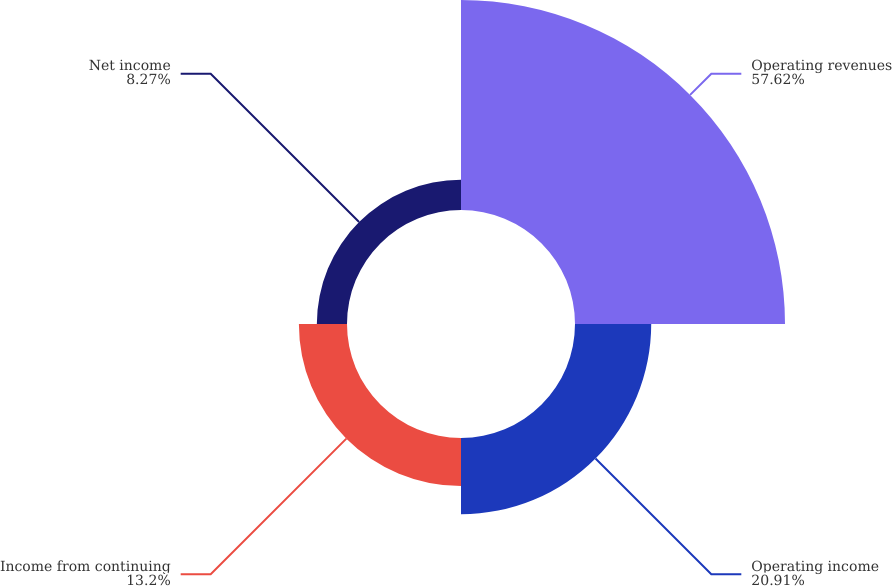Convert chart. <chart><loc_0><loc_0><loc_500><loc_500><pie_chart><fcel>Operating revenues<fcel>Operating income<fcel>Income from continuing<fcel>Net income<nl><fcel>57.61%<fcel>20.91%<fcel>13.2%<fcel>8.27%<nl></chart> 